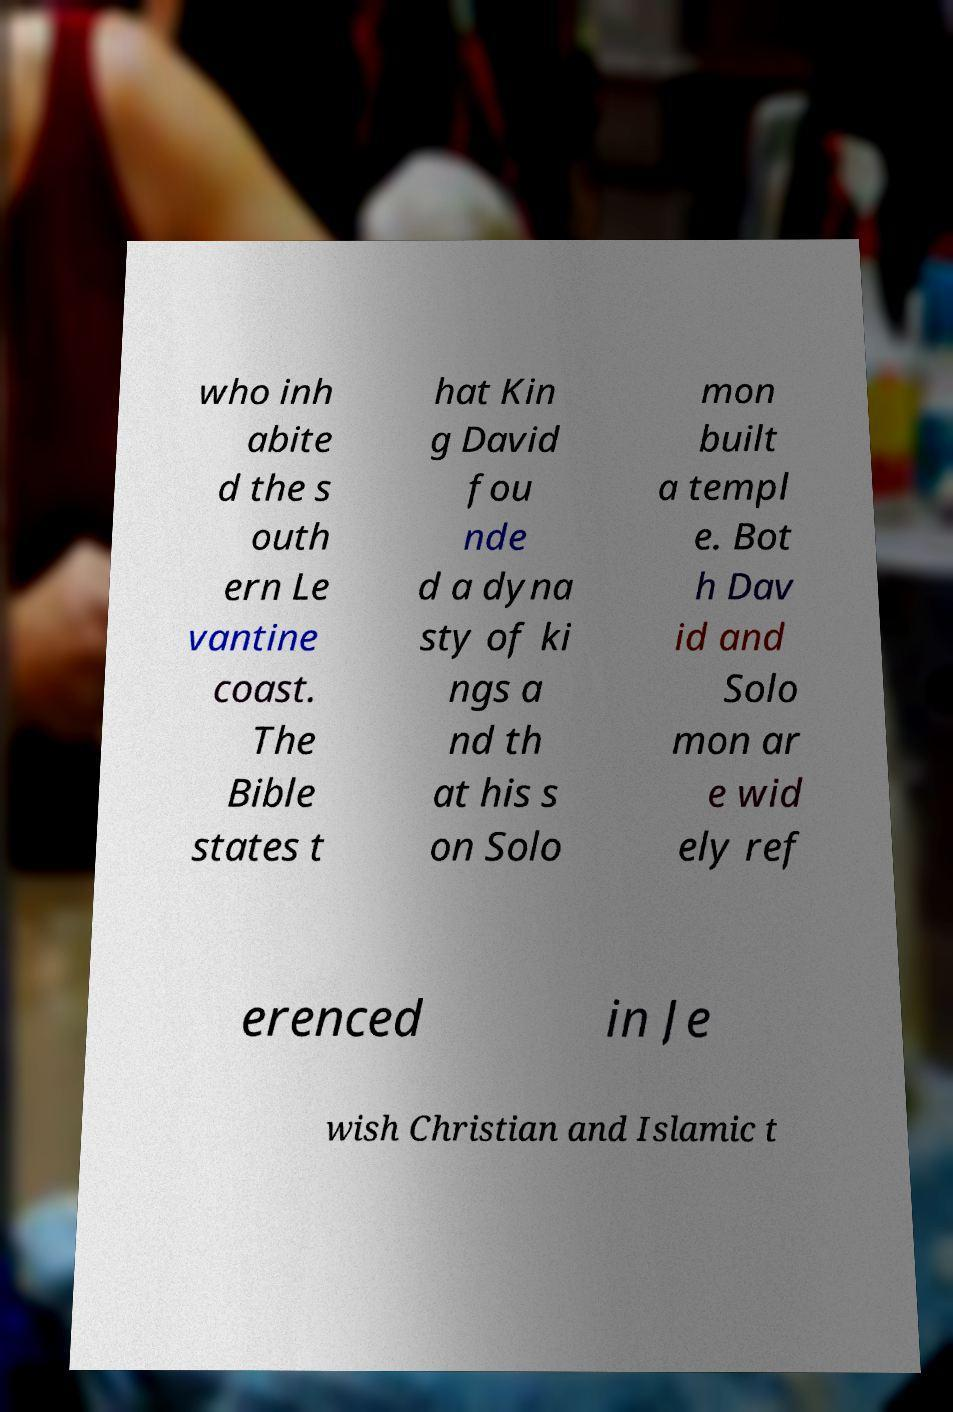For documentation purposes, I need the text within this image transcribed. Could you provide that? who inh abite d the s outh ern Le vantine coast. The Bible states t hat Kin g David fou nde d a dyna sty of ki ngs a nd th at his s on Solo mon built a templ e. Bot h Dav id and Solo mon ar e wid ely ref erenced in Je wish Christian and Islamic t 